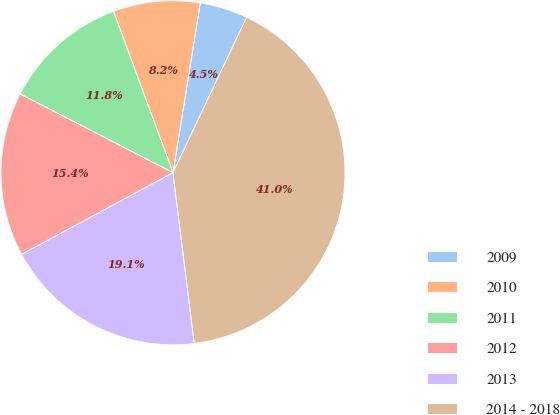<chart> <loc_0><loc_0><loc_500><loc_500><pie_chart><fcel>2009<fcel>2010<fcel>2011<fcel>2012<fcel>2013<fcel>2014 - 2018<nl><fcel>4.51%<fcel>8.16%<fcel>11.8%<fcel>15.45%<fcel>19.1%<fcel>40.99%<nl></chart> 